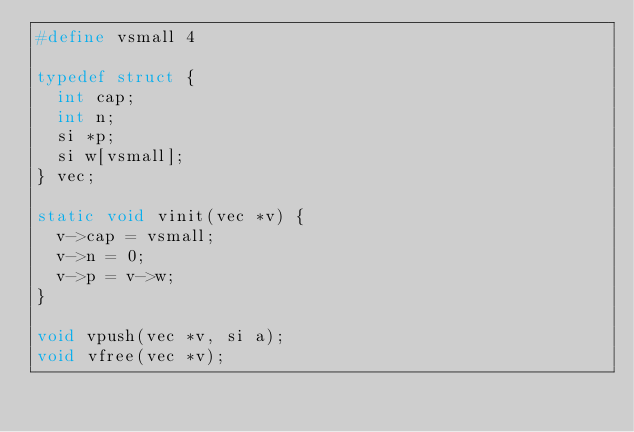<code> <loc_0><loc_0><loc_500><loc_500><_C_>#define vsmall 4

typedef struct {
  int cap;
  int n;
  si *p;
  si w[vsmall];
} vec;

static void vinit(vec *v) {
  v->cap = vsmall;
  v->n = 0;
  v->p = v->w;
}

void vpush(vec *v, si a);
void vfree(vec *v);
</code> 